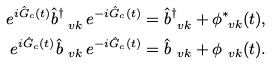Convert formula to latex. <formula><loc_0><loc_0><loc_500><loc_500>e ^ { i \hat { G } _ { c } ( t ) } \hat { b } _ { \ v k } ^ { \dagger } \, e ^ { - i \hat { G } _ { c } ( t ) } & = \hat { b } _ { \ v k } ^ { \dagger } + \phi _ { \ v k } ^ { * } ( t ) , \\ e ^ { i \hat { G } _ { c } ( t ) } \hat { b } _ { \ v k } \, e ^ { - i \hat { G } _ { c } ( t ) } & = \hat { b } _ { \ v k } + \phi _ { \ v k } ( t ) .</formula> 